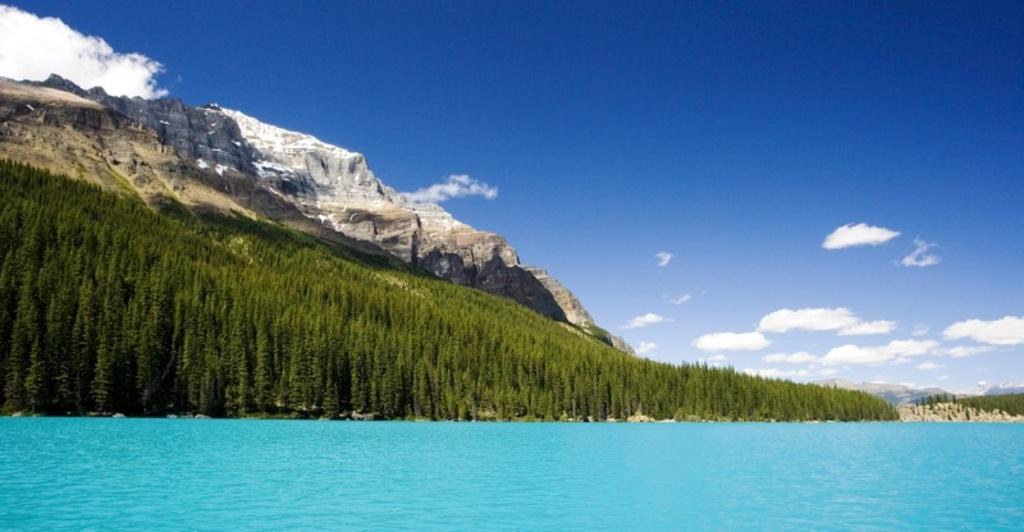What type of natural body of water is visible in the image? There is a sea in the image. What is located behind the sea? There are trees and mountains behind the sea. What can be seen in the sky at the top of the image? Clouds are visible in the sky at the top of the image. What type of corn can be seen growing in the sea in the image? There is no corn visible in the image, as it features a sea with trees and mountains in the background. 